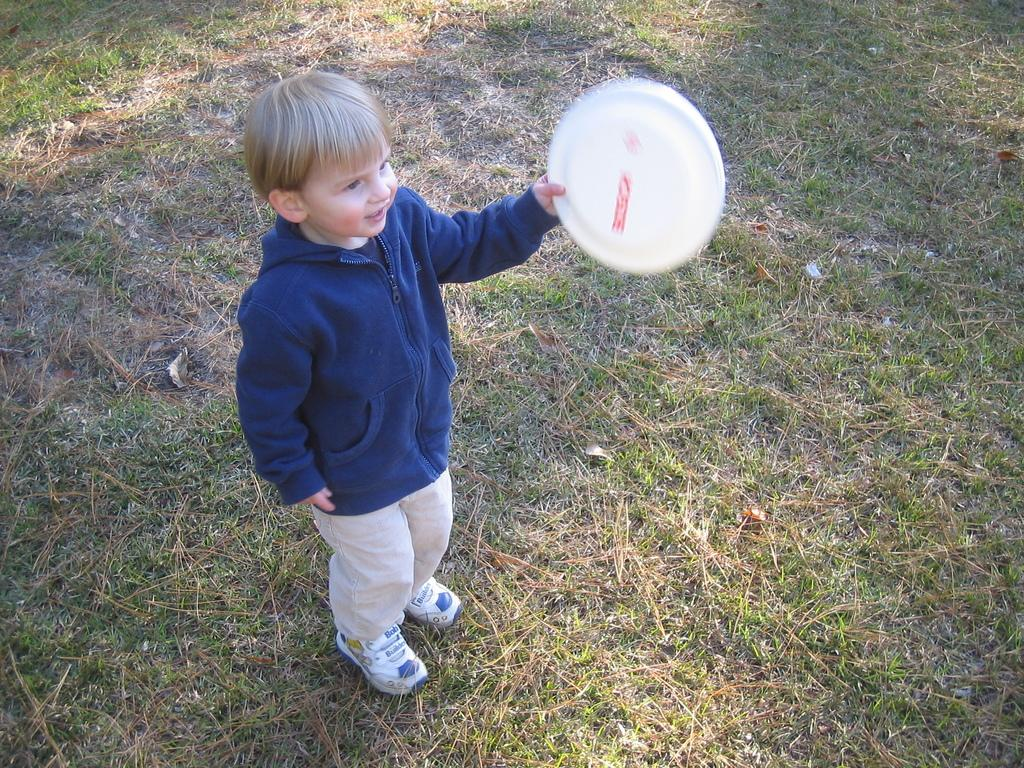Who is the main subject in the image? There is a boy in the image. What is the boy wearing? The boy is wearing a blue jacket and white shoes. What is the boy holding in the image? The boy is holding a frisbee. What is the ground covered with in the image? There is green grass on the ground. Can you tell me about the design of the bone in the image? There is no bone present in the image; it features a boy holding a frisbee on green grass. 